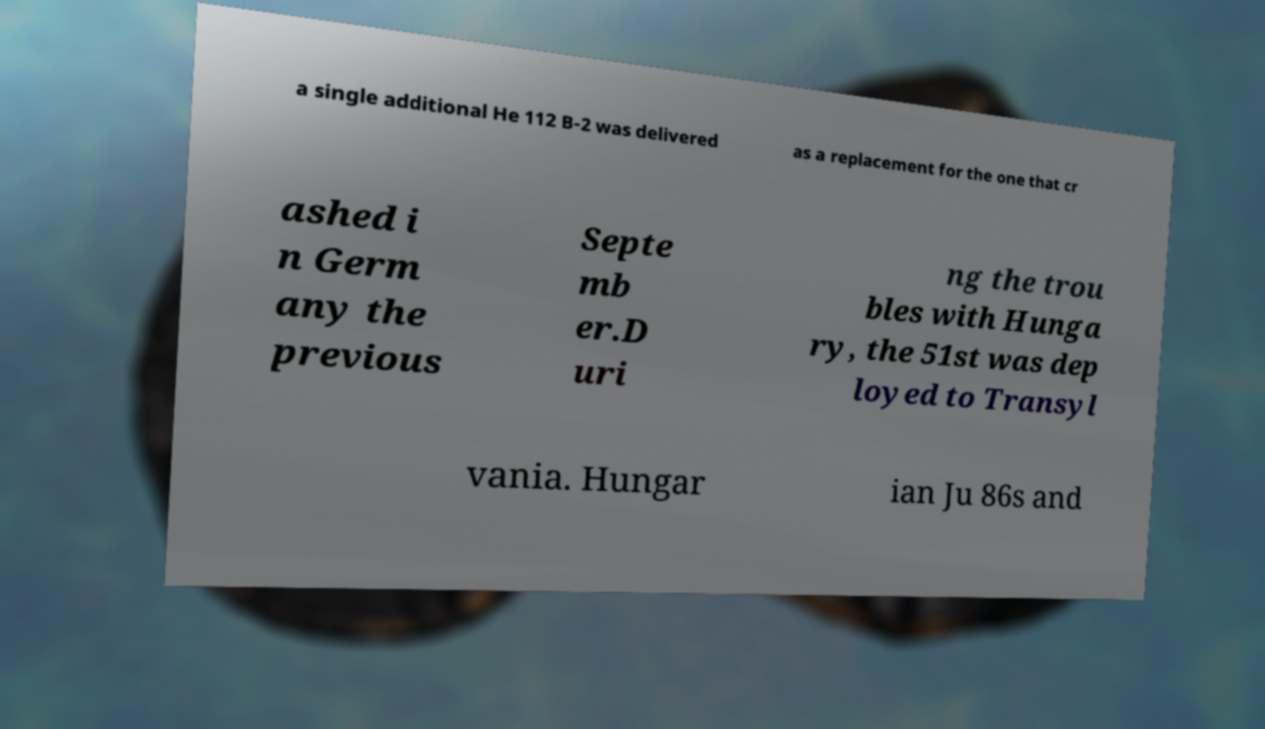Could you extract and type out the text from this image? a single additional He 112 B-2 was delivered as a replacement for the one that cr ashed i n Germ any the previous Septe mb er.D uri ng the trou bles with Hunga ry, the 51st was dep loyed to Transyl vania. Hungar ian Ju 86s and 